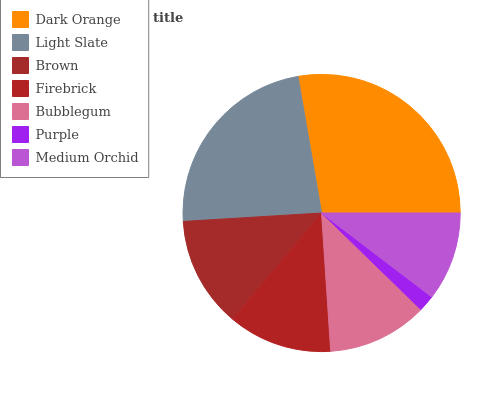Is Purple the minimum?
Answer yes or no. Yes. Is Dark Orange the maximum?
Answer yes or no. Yes. Is Light Slate the minimum?
Answer yes or no. No. Is Light Slate the maximum?
Answer yes or no. No. Is Dark Orange greater than Light Slate?
Answer yes or no. Yes. Is Light Slate less than Dark Orange?
Answer yes or no. Yes. Is Light Slate greater than Dark Orange?
Answer yes or no. No. Is Dark Orange less than Light Slate?
Answer yes or no. No. Is Firebrick the high median?
Answer yes or no. Yes. Is Firebrick the low median?
Answer yes or no. Yes. Is Brown the high median?
Answer yes or no. No. Is Brown the low median?
Answer yes or no. No. 